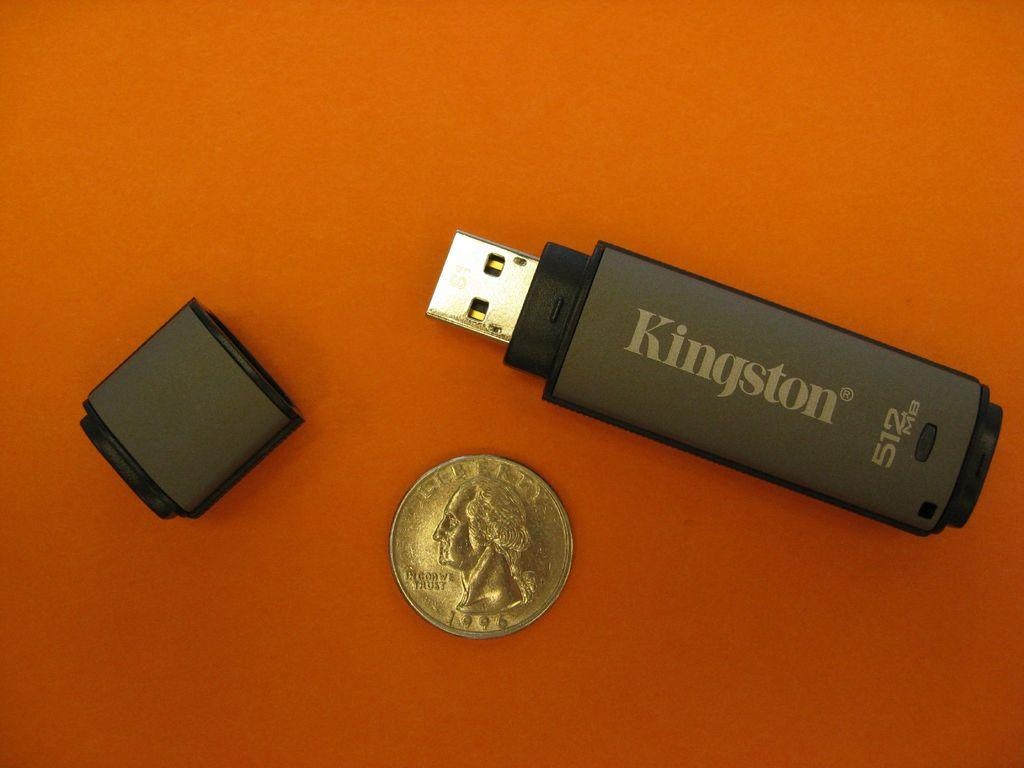<image>
Present a compact description of the photo's key features. The Kingston thumb drive is a bit larger than a quarter. 